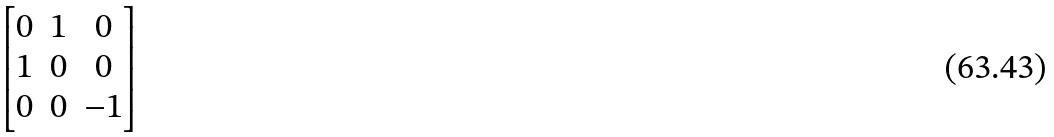Convert formula to latex. <formula><loc_0><loc_0><loc_500><loc_500>\begin{bmatrix} 0 & 1 & 0 \\ 1 & 0 & 0 \\ 0 & 0 & - 1 \end{bmatrix}</formula> 